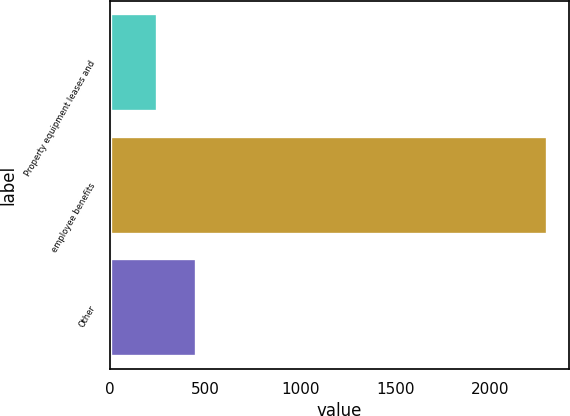Convert chart to OTSL. <chart><loc_0><loc_0><loc_500><loc_500><bar_chart><fcel>Property equipment leases and<fcel>employee benefits<fcel>Other<nl><fcel>248<fcel>2300<fcel>453.2<nl></chart> 